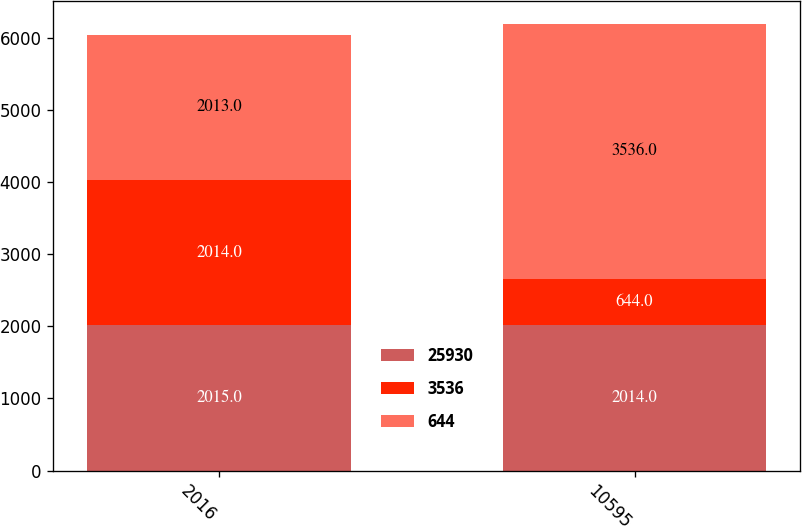<chart> <loc_0><loc_0><loc_500><loc_500><stacked_bar_chart><ecel><fcel>2016<fcel>10595<nl><fcel>25930<fcel>2015<fcel>2014<nl><fcel>3536<fcel>2014<fcel>644<nl><fcel>644<fcel>2013<fcel>3536<nl></chart> 